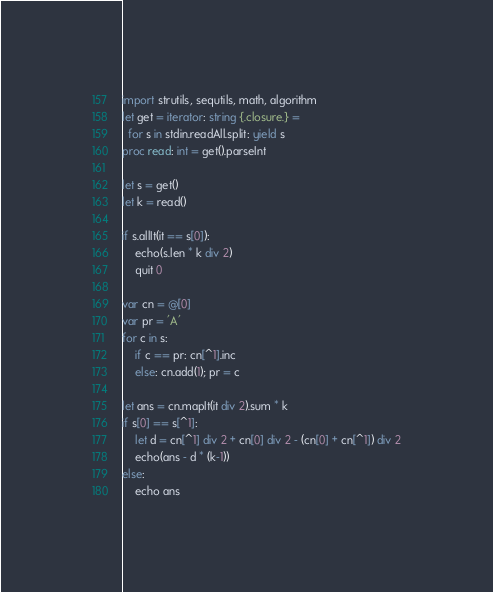Convert code to text. <code><loc_0><loc_0><loc_500><loc_500><_Nim_>import strutils, sequtils, math, algorithm
let get = iterator: string {.closure.} =
  for s in stdin.readAll.split: yield s
proc read: int = get().parseInt

let s = get()
let k = read()

if s.allIt(it == s[0]):
    echo(s.len * k div 2)
    quit 0

var cn = @[0]
var pr = 'A'
for c in s:
    if c == pr: cn[^1].inc
    else: cn.add(1); pr = c

let ans = cn.mapIt(it div 2).sum * k
if s[0] == s[^1]:
    let d = cn[^1] div 2 + cn[0] div 2 - (cn[0] + cn[^1]) div 2
    echo(ans - d * (k-1))
else:
    echo ans
</code> 